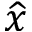<formula> <loc_0><loc_0><loc_500><loc_500>\widehat { x }</formula> 